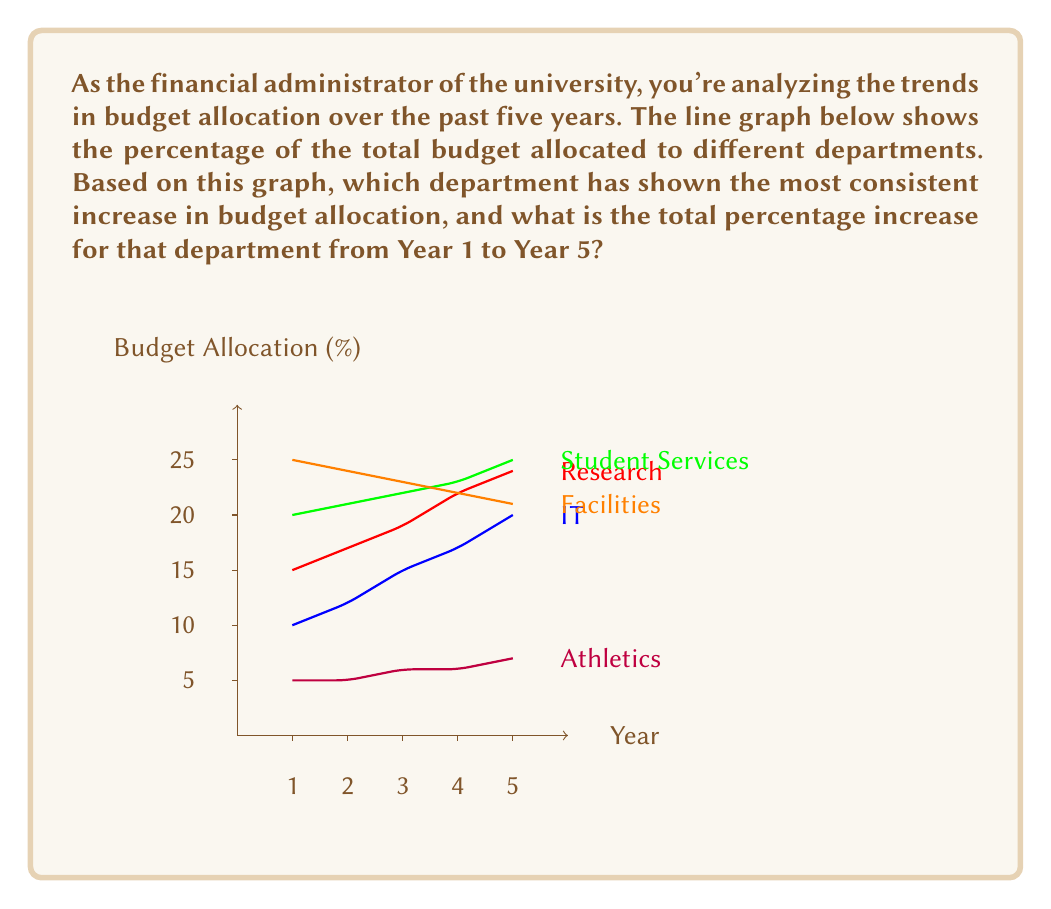What is the answer to this math problem? To answer this question, we need to:
1. Identify the department with the most consistent increase
2. Calculate the total percentage increase for that department

Step 1: Identifying the department with the most consistent increase
Looking at the graph, we can see that:
- Research shows a consistent increase, but with varying slopes
- IT shows a consistent increase, with a relatively steady slope
- Student Services shows a consistent but slow increase
- Facilities shows a consistent decrease
- Athletics shows a slight increase, but remains mostly flat

The department with the most consistent increase appears to be IT.

Step 2: Calculating the total percentage increase for IT
We need to find the difference between Year 5 and Year 1 values for IT.

Year 1 value: 10%
Year 5 value: 20%

Total increase: $20\% - 10\% = 10\%$

To verify this is the correct department, let's quickly check the others:
Research: $24\% - 15\% = 9\%$
Student Services: $25\% - 20\% = 5\%$
Facilities: Decreasing
Athletics: $7\% - 5\% = 2\%$

This confirms that IT has both the most consistent increase and the largest total increase.
Answer: IT department; 10% 